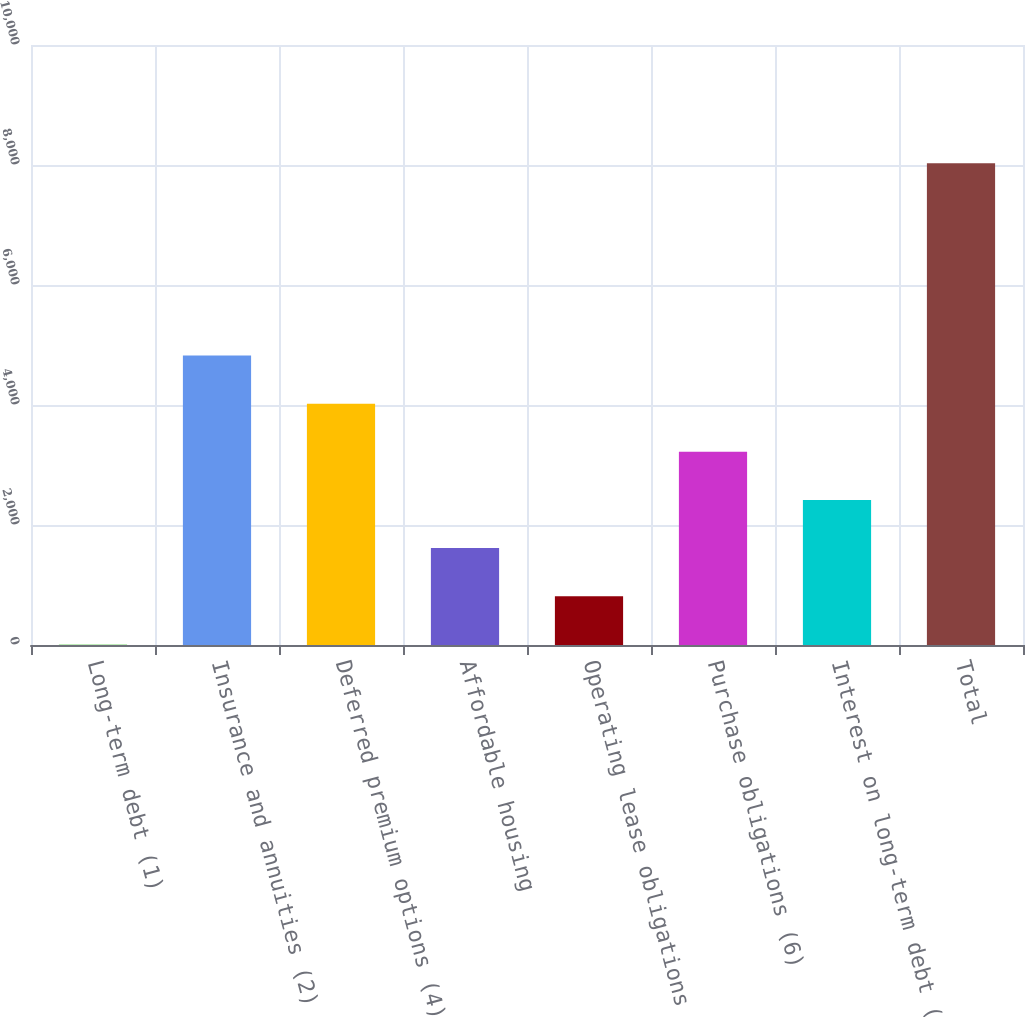Convert chart. <chart><loc_0><loc_0><loc_500><loc_500><bar_chart><fcel>Long-term debt (1)<fcel>Insurance and annuities (2)<fcel>Deferred premium options (4)<fcel>Affordable housing<fcel>Operating lease obligations<fcel>Purchase obligations (6)<fcel>Interest on long-term debt (7)<fcel>Total<nl><fcel>11<fcel>4823<fcel>4021<fcel>1615<fcel>813<fcel>3219<fcel>2417<fcel>8031<nl></chart> 